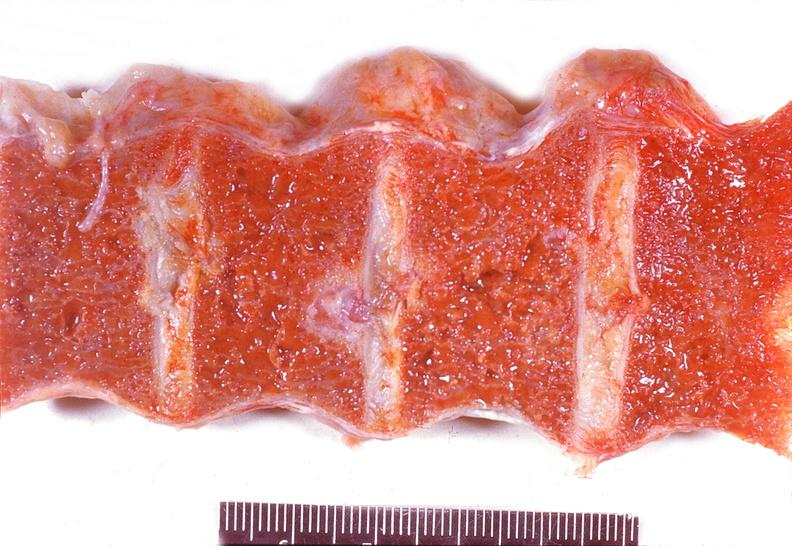does this image show vertebral column, schmorl 's node, secondary hyperparathyroidism?
Answer the question using a single word or phrase. Yes 